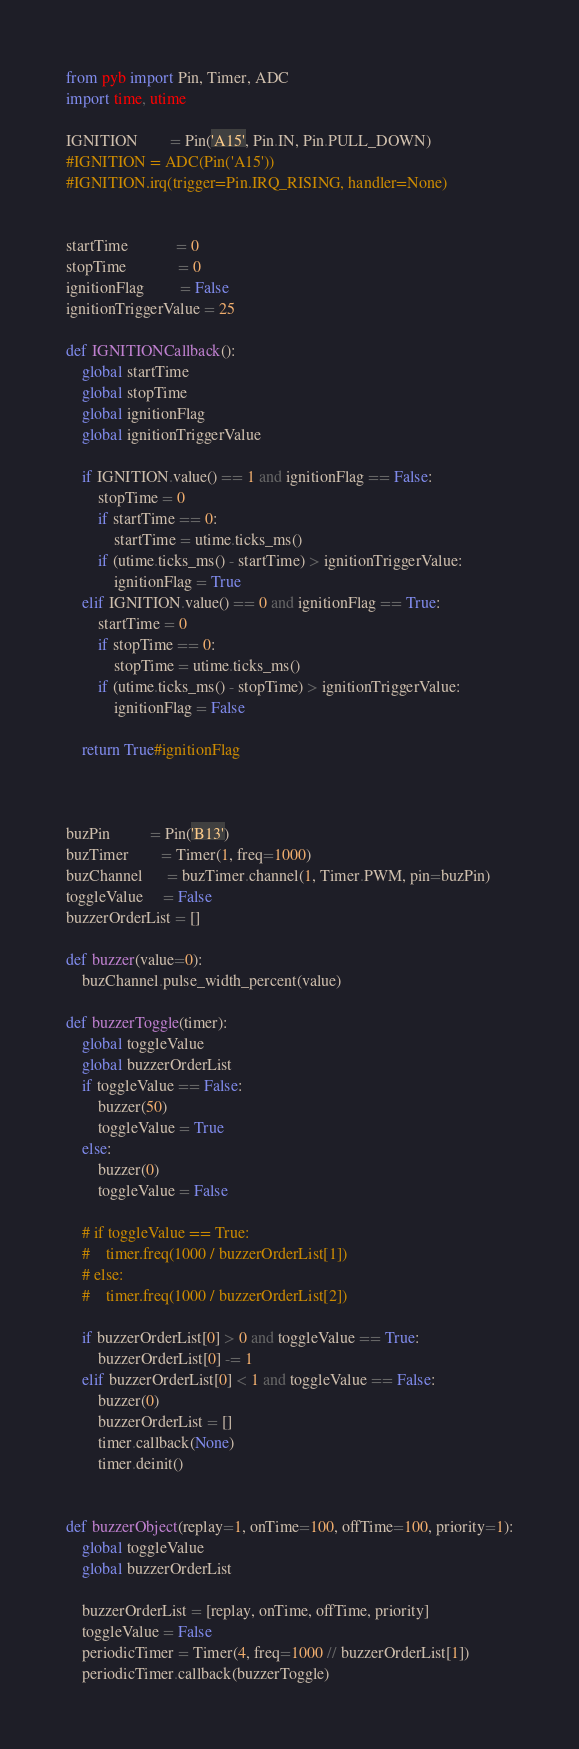<code> <loc_0><loc_0><loc_500><loc_500><_Python_>from pyb import Pin, Timer, ADC
import time, utime

IGNITION        = Pin('A15', Pin.IN, Pin.PULL_DOWN)
#IGNITION = ADC(Pin('A15'))
#IGNITION.irq(trigger=Pin.IRQ_RISING, handler=None)


startTime            = 0
stopTime             = 0
ignitionFlag         = False
ignitionTriggerValue = 25

def IGNITIONCallback():
    global startTime
    global stopTime
    global ignitionFlag
    global ignitionTriggerValue

    if IGNITION.value() == 1 and ignitionFlag == False:
        stopTime = 0
        if startTime == 0:
            startTime = utime.ticks_ms()
        if (utime.ticks_ms() - startTime) > ignitionTriggerValue:
            ignitionFlag = True
    elif IGNITION.value() == 0 and ignitionFlag == True:
        startTime = 0
        if stopTime == 0:
            stopTime = utime.ticks_ms()
        if (utime.ticks_ms() - stopTime) > ignitionTriggerValue:
            ignitionFlag = False

    return True#ignitionFlag



buzPin          = Pin('B13')
buzTimer        = Timer(1, freq=1000)
buzChannel      = buzTimer.channel(1, Timer.PWM, pin=buzPin)
toggleValue     = False
buzzerOrderList = []

def buzzer(value=0):
    buzChannel.pulse_width_percent(value)

def buzzerToggle(timer):
    global toggleValue
    global buzzerOrderList
    if toggleValue == False:
        buzzer(50)
        toggleValue = True
    else:
        buzzer(0)
        toggleValue = False

    # if toggleValue == True:
    #    timer.freq(1000 / buzzerOrderList[1])
    # else:
    #    timer.freq(1000 / buzzerOrderList[2])

    if buzzerOrderList[0] > 0 and toggleValue == True:
        buzzerOrderList[0] -= 1
    elif buzzerOrderList[0] < 1 and toggleValue == False:
        buzzer(0)
        buzzerOrderList = []
        timer.callback(None)
        timer.deinit()


def buzzerObject(replay=1, onTime=100, offTime=100, priority=1):
    global toggleValue
    global buzzerOrderList

    buzzerOrderList = [replay, onTime, offTime, priority]
    toggleValue = False
    periodicTimer = Timer(4, freq=1000 // buzzerOrderList[1])
    periodicTimer.callback(buzzerToggle)
</code> 